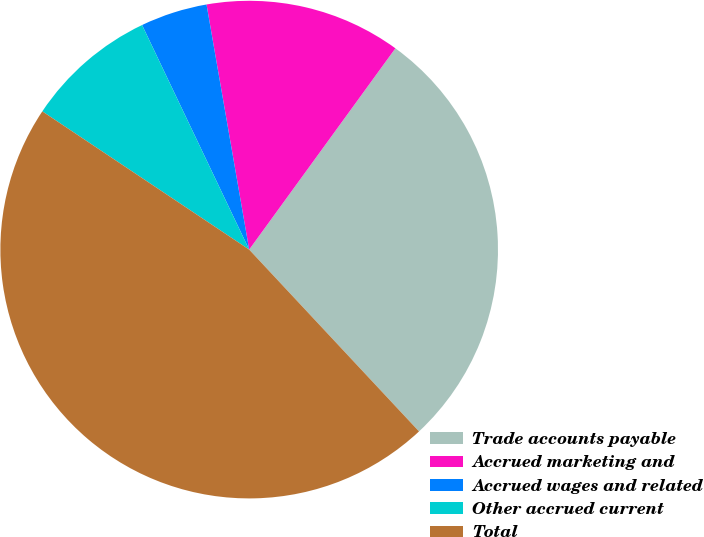Convert chart. <chart><loc_0><loc_0><loc_500><loc_500><pie_chart><fcel>Trade accounts payable<fcel>Accrued marketing and<fcel>Accrued wages and related<fcel>Other accrued current<fcel>Total<nl><fcel>28.04%<fcel>12.74%<fcel>4.34%<fcel>8.54%<fcel>46.33%<nl></chart> 